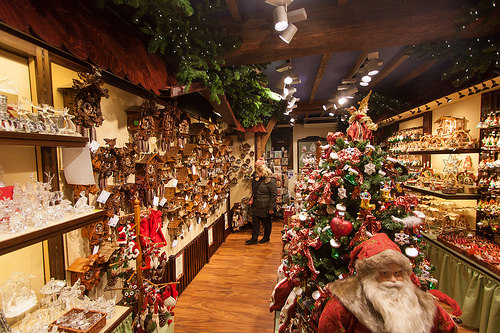<image>
Can you confirm if the christmas tree is next to the santa? Yes. The christmas tree is positioned adjacent to the santa, located nearby in the same general area. 